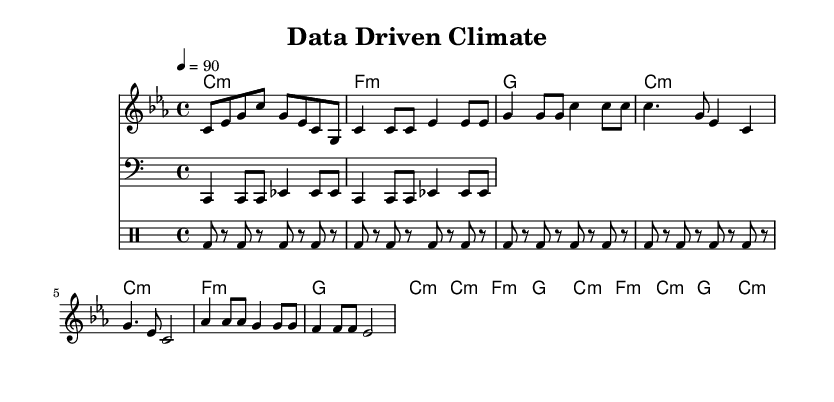What is the key signature of this music? The key signature is C minor, indicated by the three flat notes B, E, and A on the staff.
Answer: C minor What is the time signature of this music? The time signature is noted as 4/4, which means four beats per measure and a quarter note gets one beat.
Answer: 4/4 What is the tempo marking of this music? The tempo is marked as quarter note equals 90, which indicates the speed at which the music should be played.
Answer: 90 How many measures are in the chorus section? The chorus consists of two measures, as seen directly in the sheet music.
Answer: 2 Which instrument plays the drum pattern? The drum pattern is played by the DrumStaff, as indicated by the notation in the corresponding staff.
Answer: DrumStaff Describe the chord progression in the verse. The chord progression in the verse is C minor, F minor, G, C minor, which shows the harmonic structure used for that section.
Answer: C minor, F minor, G, C minor What is the rhythm pattern for the bass in the first part? The bass rhythm pattern consists of sustained quarter notes and eighth notes, corresponding to the notes provided in the bass staff.
Answer: Quarter notes and eighth notes 